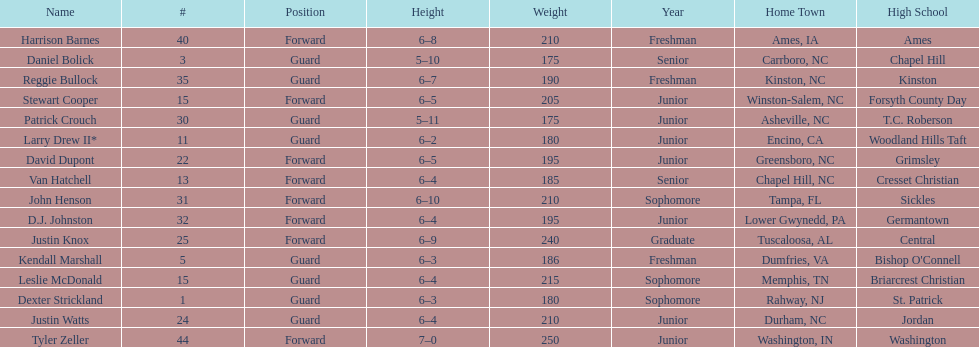How many players were taller than van hatchell? 7. 